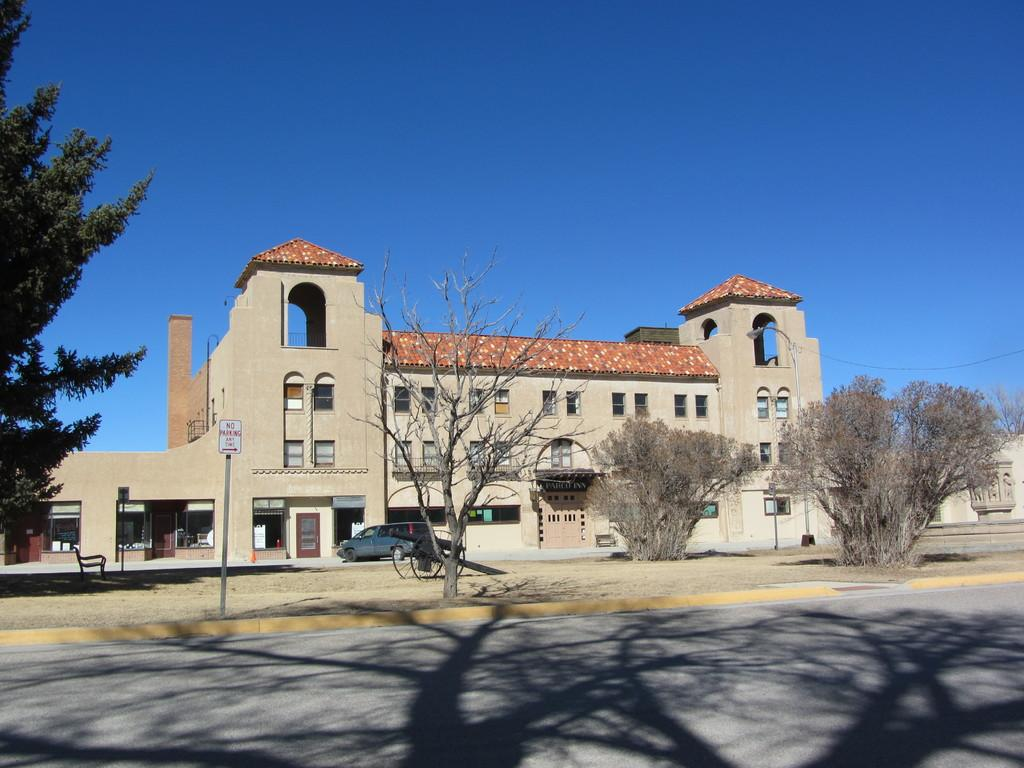What type of pathway is visible in the image? There is a road in the image. What mode of transportation can be seen on the road? There is a car in the image. What type of furniture is present in the image? There is a chair in the image. What type of vegetation is visible in the image? There are trees in the image. What type of structure is present in the image? There are boards on poles in the image. What type of building is visible in the image? There is a building in the image. What is visible in the background of the image? The sky is visible in the background of the image, and it is blue in color. Can you hear the respectful ear in the image? There is no ear or respectful sound present in the image. What type of liquid is flowing through the road in the image? There is no liquid flowing through the road in the image; it is a solid surface for vehicles to travel on. 